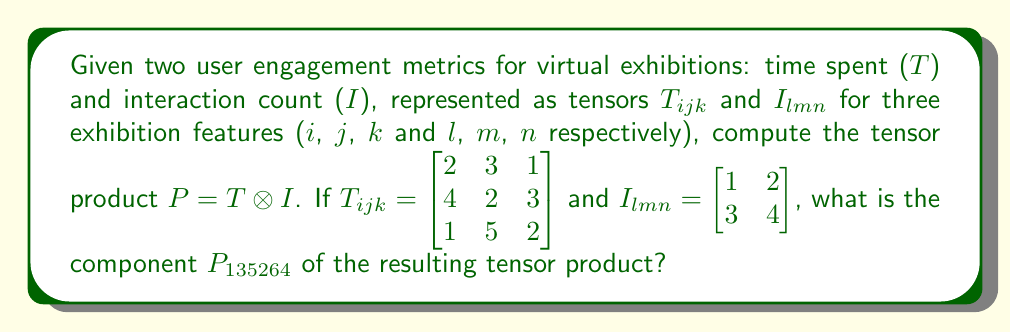Teach me how to tackle this problem. To solve this problem, we'll follow these steps:

1) The tensor product $P = T \otimes I$ is defined as:

   $$P_{ijklmn} = T_{ijk} \cdot I_{lmn}$$

2) The resulting tensor P will have 6 indices (i, j, k, l, m, n), where i, j, k come from T and l, m, n come from I.

3) We need to find $P_{135264}$, which corresponds to:
   - i = 1, j = 3, k = 5 from T
   - l = 2, m = 6, n = 4 from I

4) From the given T tensor:
   $T_{135} = 1$

5) From the given I tensor:
   $I_{264} = 4$

6) Therefore:

   $$P_{135264} = T_{135} \cdot I_{264} = 1 \cdot 4 = 4$$
Answer: $4$ 